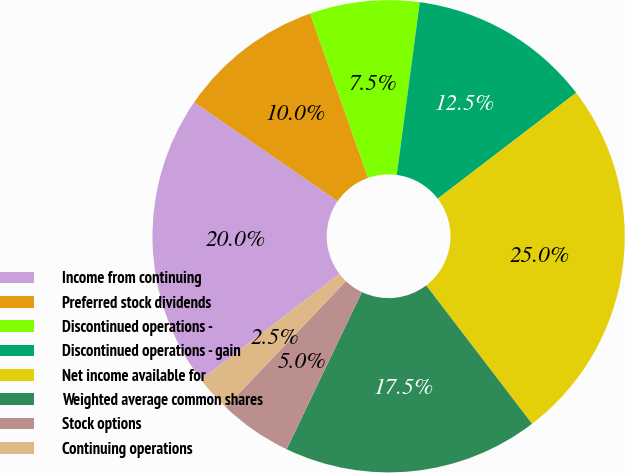Convert chart to OTSL. <chart><loc_0><loc_0><loc_500><loc_500><pie_chart><fcel>Income from continuing<fcel>Preferred stock dividends<fcel>Discontinued operations -<fcel>Discontinued operations - gain<fcel>Net income available for<fcel>Weighted average common shares<fcel>Stock options<fcel>Continuing operations<nl><fcel>20.0%<fcel>10.0%<fcel>7.5%<fcel>12.5%<fcel>25.0%<fcel>17.5%<fcel>5.0%<fcel>2.5%<nl></chart> 